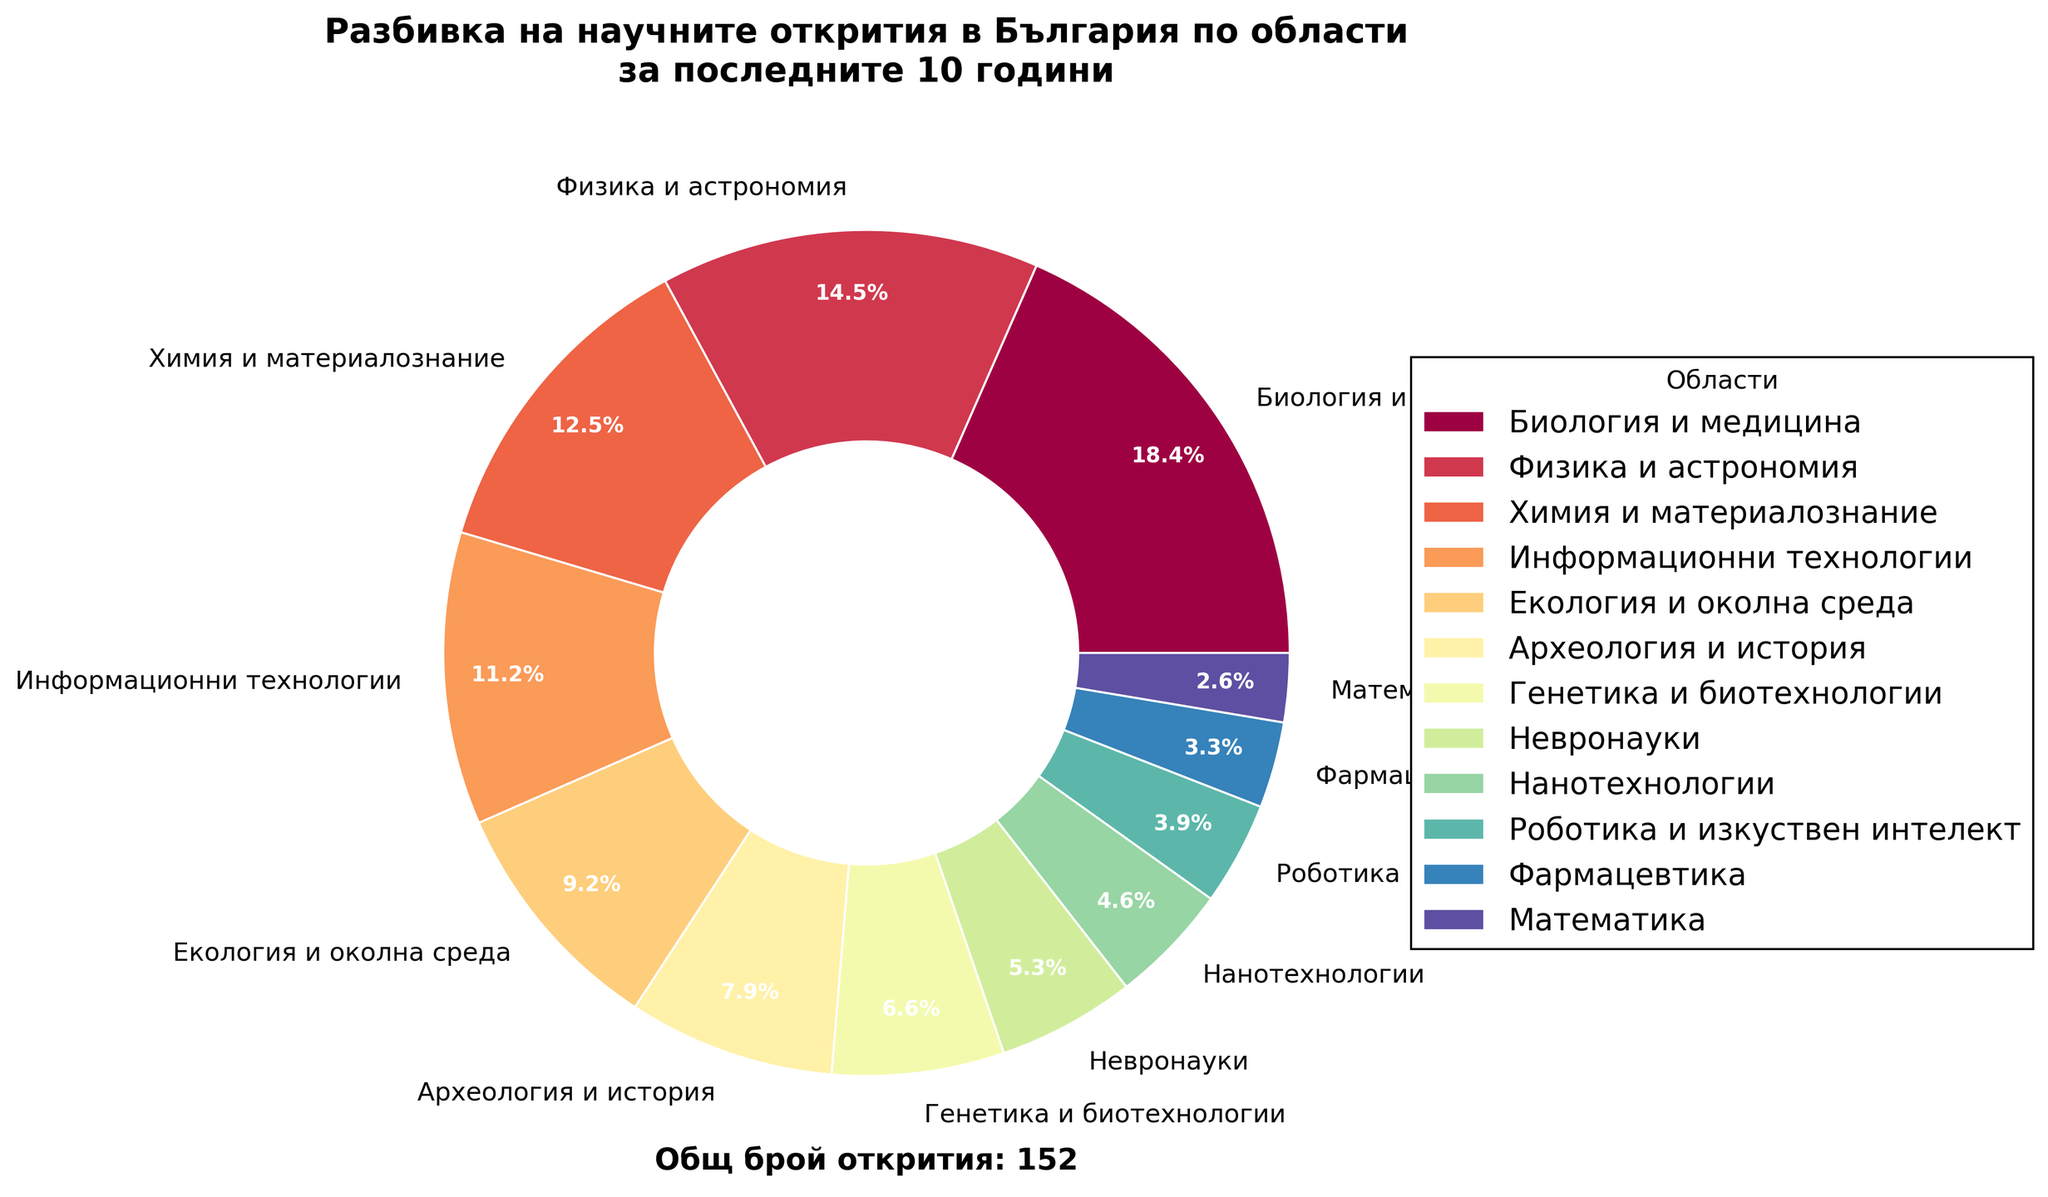Коя област има най-голям брой научни открития? Поглеждаме към областта с най-голямо парче от пая. Биология и медицина заема най-голямо парче със своите 28 открития.
Answer: Биология и медицина Колко общо научни открития има в България за последните 10 години? На графиката е означена общата сума на откритията в долната част: 152 открития
Answer: 152 Коя е областта с най-малък брой научни открития? Най-малкото парче от пая е за Математика с 4 открития.
Answer: Математика Колко пъти повече открития има в "Биология и медицина" в сравнение с "Математика"? "Биология и медицина" има 28 открития, а "Математика" има 4 открития. 28 разделено на 4 дава 7.
Answer: 7 пъти Какъв е процентът на научните открития в областта "Физика и астрономия"? Поглеждаме процента, който е отбелязан на парчето от пая за "Физика и астрономия", който е 14.5%.
Answer: 14.5% Кои области имат под 10% от общите научни открития? Първо, трябва да определим които парчета от пая са под 10%. Виждаме, че "Археология и история", "Генетика и биотехнологии", "Невронауки", "Нанотехнологии", "Роботика и изкуствен интелект", "Фармацевтика" и "Математика" са всички под 10%.
Answer: Археология и история, Генетика и биотехнологии, Невронауки, Нанотехнологии, Роботика и изкуствен интелект, Фармацевтика, Математика Колко общо са научните открития в областите "Информационни технологии" и "Екология и околна среда"? Поглеждаме броя на откритията за "Информационни технологии" (17) и "Екология и околна среда" (14). Общият брой е 17 + 14 = 31.
Answer: 31 Колко открития по-малко има в "Химия и материалознание" в сравнение с "Биология и медицина"? Поглеждаме броя на откритията за "Химия и материалознание" (19) и за "Биология и медицина" (28). Разликата е 28 - 19 = 9.
Answer: 9 Колко процента от откритията са в областите "Генетика и биотехнологии" и "Невронауки" заедно? Първо намираме броя на откритията за "Генетика и биотехнологии" (10) и "Невронауки" (8), след това събираме броя открития (10 + 8 = 18). Общо открития са 152, така че процентът е (18 / 152) * 100 = 11.8%.
Answer: 11.8% Кои три области имат най-близки стойности на броя научни открития? Поглеждаме парчетата от пая на графиката и виждаме, че "Химия и материалознание" (19), "Информационни технологии" (17) и "Екология и околна среда" (14) имат близки стойности.
Answer: Химия и материалознание, Информационни технологии, Екология и околна среда 